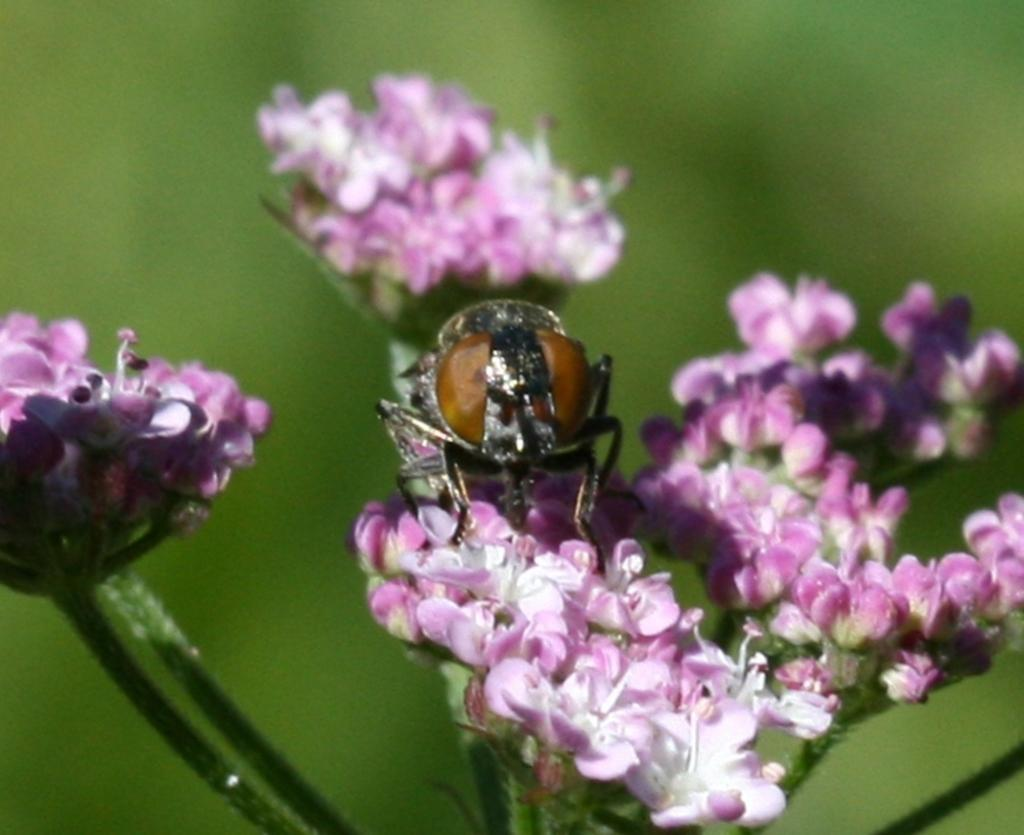What is visible in the foreground of the picture? In the foreground of the picture, there are flowers, stems, leaves, and a fly. Can you describe the flowers in the foreground? The flowers in the foreground have stems and leaves. What is the condition of the background in the image? The background of the image is blurred. What type of lunch is being served on the fly's neck in the image? There is no lunch or fly's neck present in the image. 